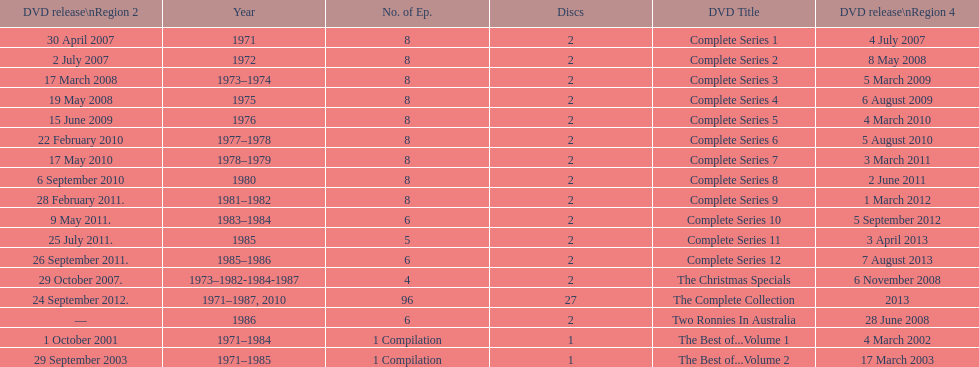What is previous to complete series 10? Complete Series 9. 